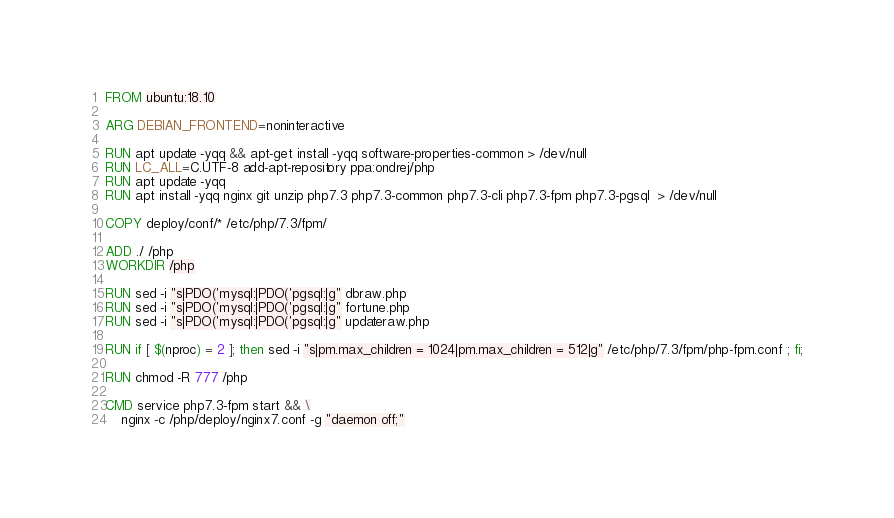Convert code to text. <code><loc_0><loc_0><loc_500><loc_500><_Dockerfile_>FROM ubuntu:18.10

ARG DEBIAN_FRONTEND=noninteractive

RUN apt update -yqq && apt-get install -yqq software-properties-common > /dev/null
RUN LC_ALL=C.UTF-8 add-apt-repository ppa:ondrej/php
RUN apt update -yqq
RUN apt install -yqq nginx git unzip php7.3 php7.3-common php7.3-cli php7.3-fpm php7.3-pgsql  > /dev/null

COPY deploy/conf/* /etc/php/7.3/fpm/

ADD ./ /php
WORKDIR /php

RUN sed -i "s|PDO('mysql:|PDO('pgsql:|g" dbraw.php
RUN sed -i "s|PDO('mysql:|PDO('pgsql:|g" fortune.php
RUN sed -i "s|PDO('mysql:|PDO('pgsql:|g" updateraw.php

RUN if [ $(nproc) = 2 ]; then sed -i "s|pm.max_children = 1024|pm.max_children = 512|g" /etc/php/7.3/fpm/php-fpm.conf ; fi;

RUN chmod -R 777 /php

CMD service php7.3-fpm start && \
    nginx -c /php/deploy/nginx7.conf -g "daemon off;"
</code> 